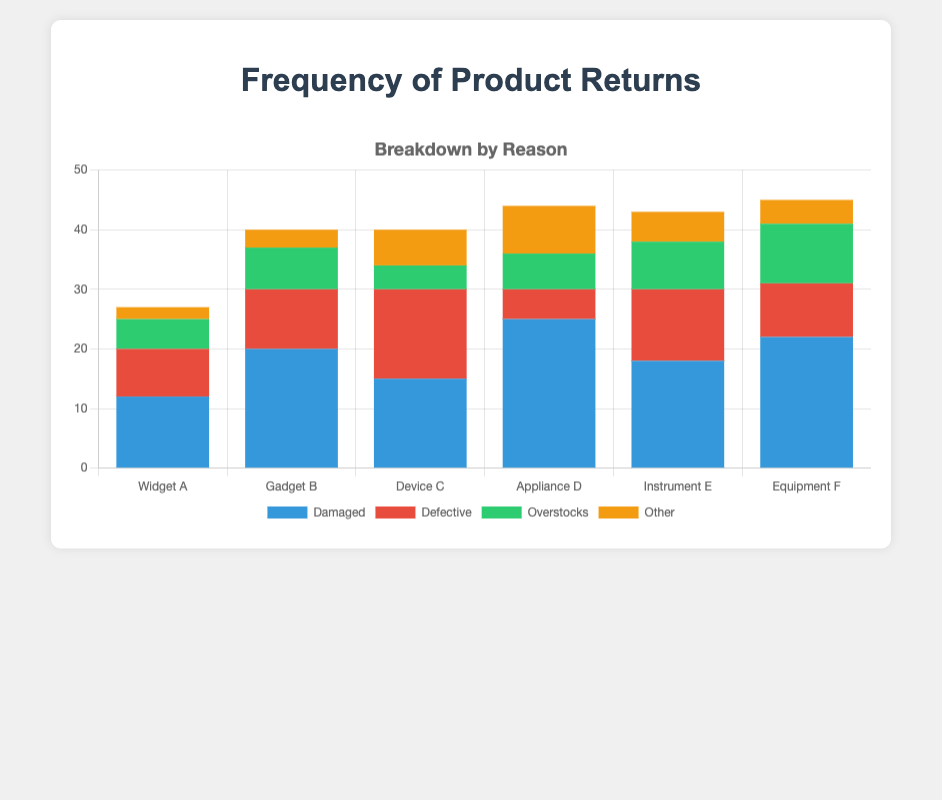Which product has the highest number of defective returns? Gadget B, Device C, and Instrument E all have defective returns represented in red bars. Gadget B and Device C both have 15 defective returns, more than any other.
Answer: Gadget B and Device C Which product has the lowest total number of returns? By summing up all reasons for each product, we find Widget A has 12 + 8 + 5 + 2 = 27 returns, which is the lowest compared to all other products.
Answer: Widget A How many total returns are due to overstock across all products? Add the overstock returns for each product: 5 + 7 + 4 + 6 + 8 + 10 = 40.
Answer: 40 What is the difference in the total number of damaged returns between Appliance D and Widget A? Appliance D has 25 damaged returns, and Widget A has 12. The difference is 25 - 12 = 13.
Answer: 13 Which product has the highest total number of returns? Summing the returns for all reasons, Appliance D has 25 + 5 + 6 + 8 = 44 returns, more than any other product.
Answer: Appliance D Compare the total returns of Instrument E and Equipment F. Which one has more and by how much? Instrument E has 18 + 12 + 8 + 5 = 43 returns; Equipment F has 22 + 9 + 10 + 4 = 45 returns. The difference is 45 - 43 = 2.
Answer: Equipment F by 2 How many products have more than 10 defective returns? Gadget B, Device C, and Instrument E have 10, 15, and 12 defective returns, respectively, which are all more than 10.
Answer: 3 products Which product has the most returns categorized as "Other"? The bars representing "Other" returns are yellow. Appliance D has 8 "Other" returns, the most among the products.
Answer: Appliance D What is the combined total of damaged and defective returns for Device C? Device C has 15 damaged and 15 defective returns. Their combined total is 15 + 15 = 30.
Answer: 30 